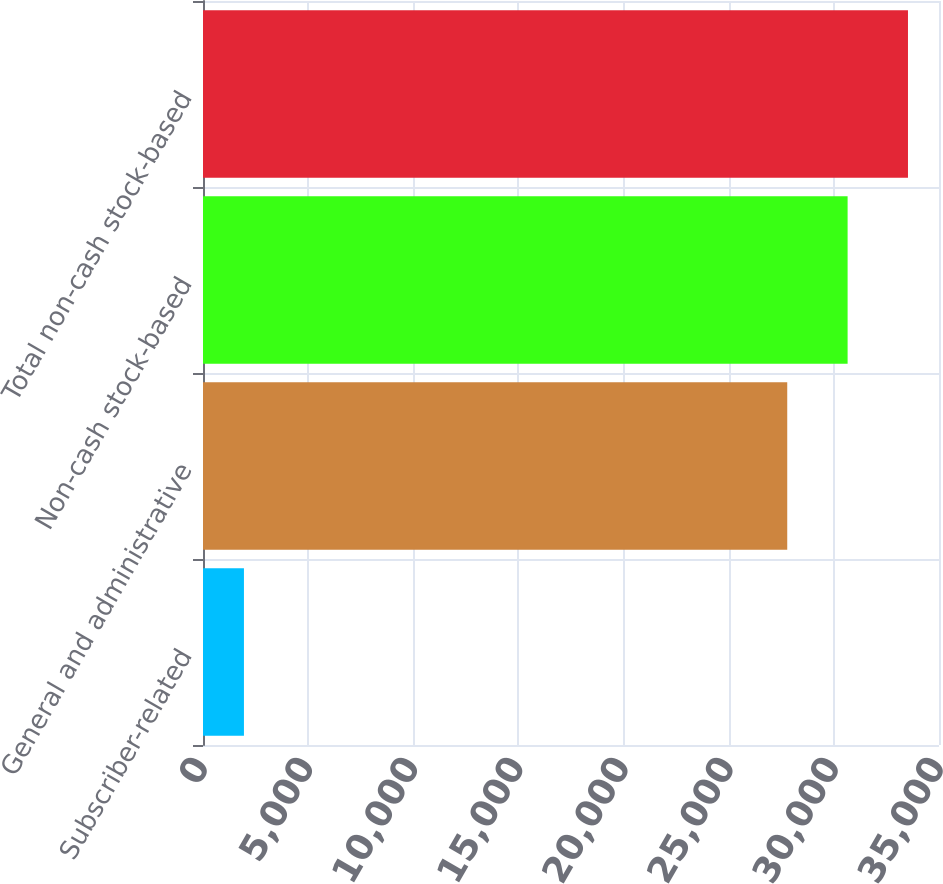Convert chart to OTSL. <chart><loc_0><loc_0><loc_500><loc_500><bar_chart><fcel>Subscriber-related<fcel>General and administrative<fcel>Non-cash stock-based<fcel>Total non-cash stock-based<nl><fcel>1947<fcel>27783<fcel>30653.8<fcel>33524.6<nl></chart> 